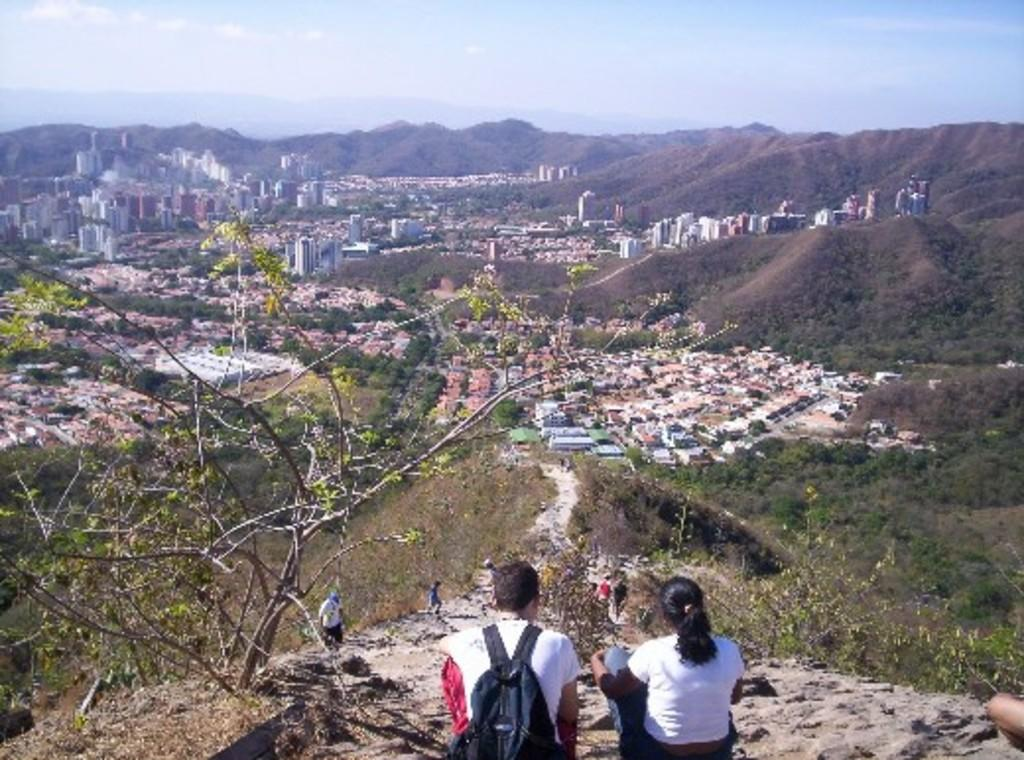How many people are in the image, and what are they wearing? There are people with different color dresses in the image. What is one person carrying in the image? One person is wearing a bag. What can be seen in the background of the image? There are trees, houses, mountains, and the sky visible in the background of the image. Reasoning: Let's think step by following the steps to produce the conversation. We start by identifying the main subjects in the image, which are the people with different color dresses. Then, we describe the specific detail of one person wearing a bag. Next, we expand the conversation to include the background of the image, mentioning the trees, houses, mountains, and sky. Each question is designed to elicit a specific detail about the image that is known from the provided facts. Absurd Question/Answer: What type of bottle is hanging from the string in the image? There is no bottle or string present in the image. What health benefits can be gained from the image? The image does not depict any health-related information or activities, so it is not possible to determine any health benefits from the image. What type of bottle is hanging from the string in the image? There is no bottle or string present in the image. 